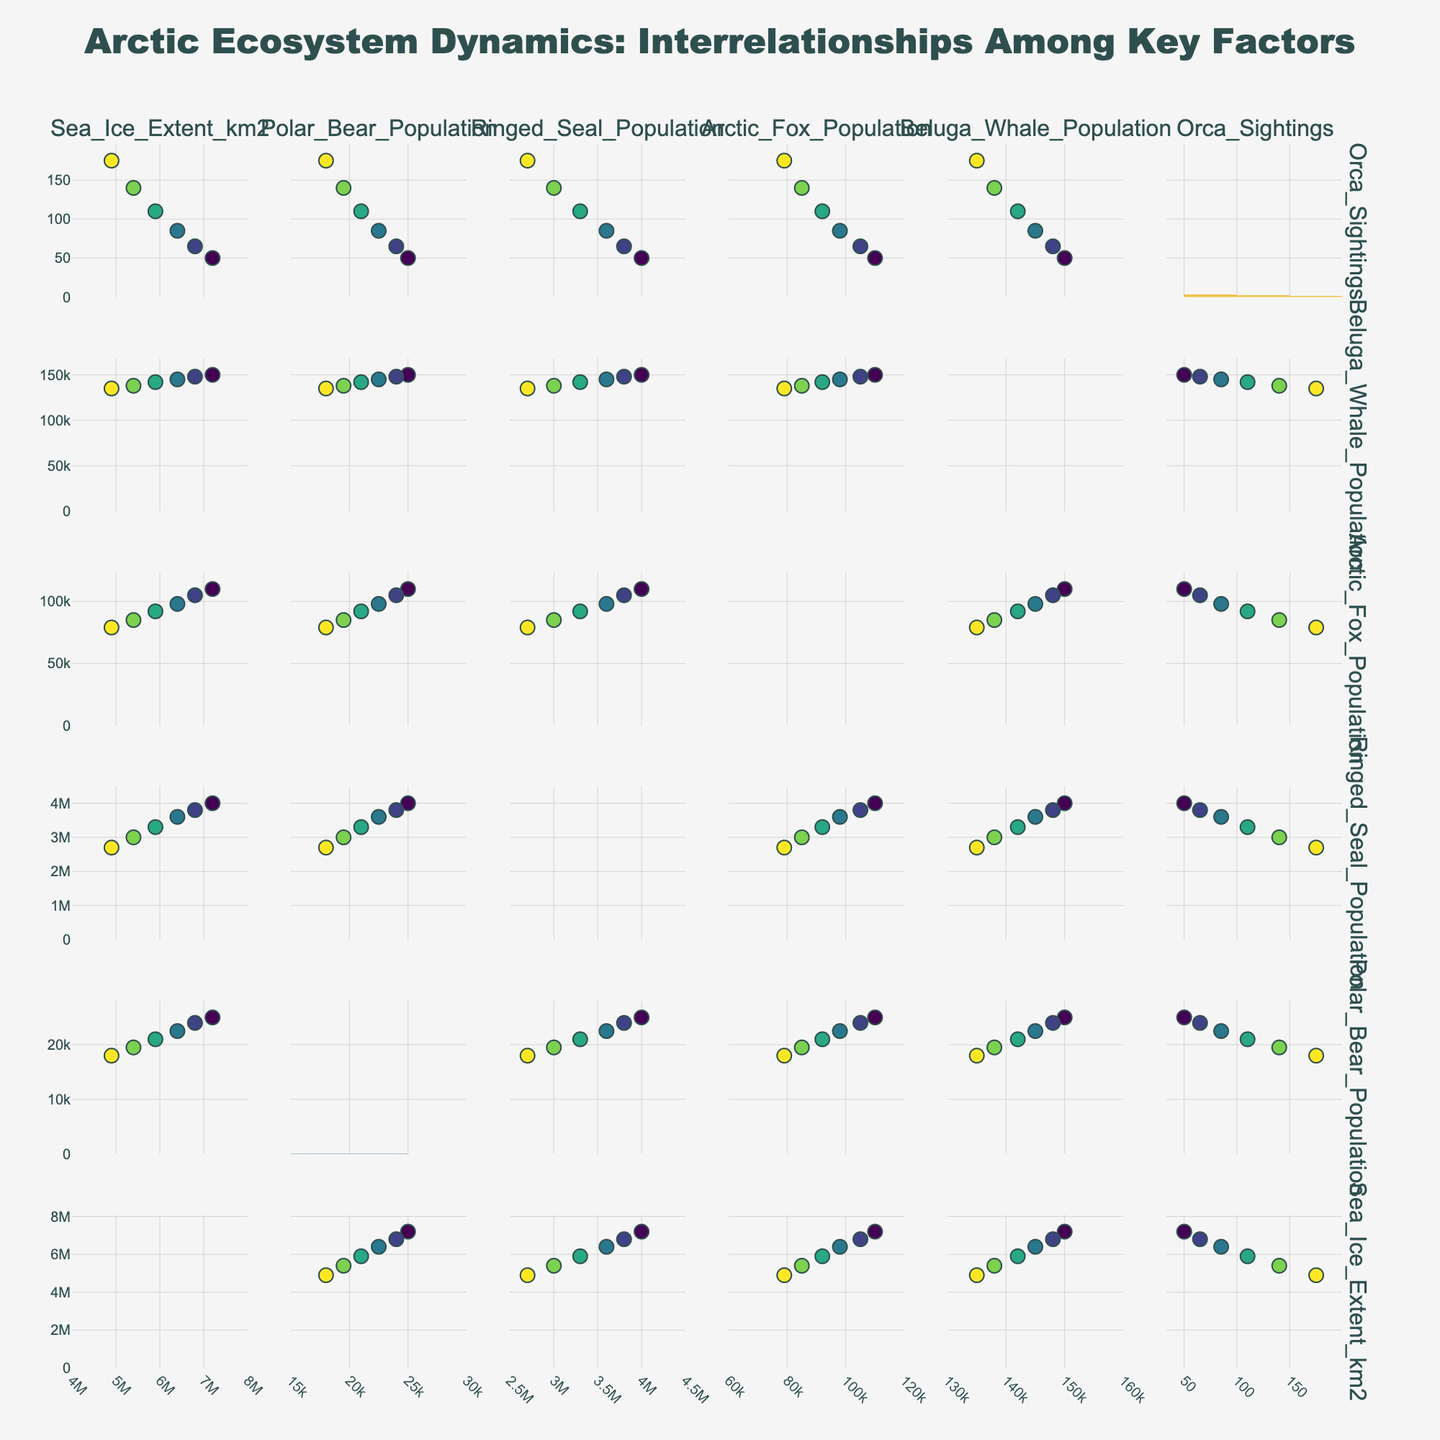What is the title of the pie chart? The title of the chart is usually displayed at the top of the figure, giving an overview of what the chart represents. By looking at the top of the pie chart, we can see it says, "Composition of Library Patronage by Age Group."
Answer: Composition of Library Patronage by Age Group Which age group has the highest percentage of library patronage? By examining the size of the slices and the labels, we can identify that the "Adults (20-64)" slice is the largest, showing that it has the highest percentage of 42%.
Answer: Adults (20-64) How many age groups are represented in the pie chart? The pie chart is divided into different slices, each representing a specific age group. By counting these slices, we can see that there are four age groups represented: Children, Teens, Adults, and Seniors.
Answer: Four What is the combined percentage of teens and seniors? To find the combined percentage, we need to sum the percentages for both Teens (15%) and Seniors (15%). 15% + 15% = 30%.
Answer: 30% How does the percentage of children compare to the percentage of teens? By comparing the labels and corresponding percentages, we can see that the Children (0-12) category has a percentage of 28%, while the Teens (13-19) category has a percentage of 15%. 28% is greater than 15%.
Answer: Children have a higher percentage than Teens What is the difference in patronage percentage between adults and children? To find the difference, subtract the percentage of Children (28%) from the percentage of Adults (42%). 42% - 28% = 14%.
Answer: 14% Which two age groups have equal percentages of library patronage? By examining the pie chart, we can see that both Teens and Seniors have the same percentage, which is 15%.
Answer: Teens and Seniors What color is used to represent the senior age group in the pie chart? The color of each slice can be identified by looking at the legend and matching it with the corresponding slice. The Seniors (65+) slice is colored in light pink.
Answer: Light pink If the total number of library patrons is 1,000, how many of them are adults? We know from the pie chart that 42% of the patrons are adults. Multiplying 42% by the total number (1,000) gives us 420 adults.
Answer: 420 